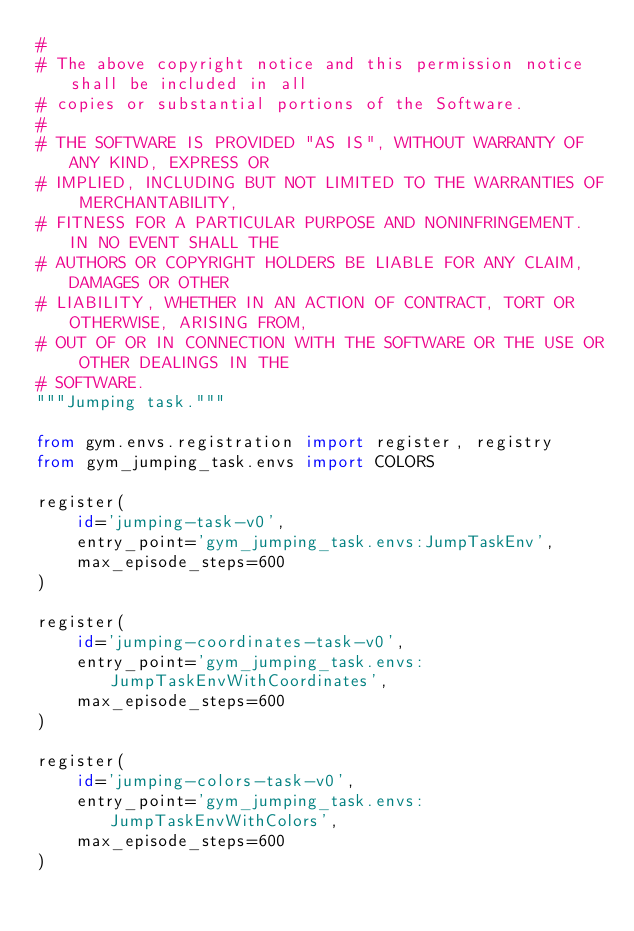<code> <loc_0><loc_0><loc_500><loc_500><_Python_>#
# The above copyright notice and this permission notice shall be included in all
# copies or substantial portions of the Software.
#
# THE SOFTWARE IS PROVIDED "AS IS", WITHOUT WARRANTY OF ANY KIND, EXPRESS OR
# IMPLIED, INCLUDING BUT NOT LIMITED TO THE WARRANTIES OF MERCHANTABILITY,
# FITNESS FOR A PARTICULAR PURPOSE AND NONINFRINGEMENT. IN NO EVENT SHALL THE
# AUTHORS OR COPYRIGHT HOLDERS BE LIABLE FOR ANY CLAIM, DAMAGES OR OTHER
# LIABILITY, WHETHER IN AN ACTION OF CONTRACT, TORT OR OTHERWISE, ARISING FROM,
# OUT OF OR IN CONNECTION WITH THE SOFTWARE OR THE USE OR OTHER DEALINGS IN THE
# SOFTWARE.
"""Jumping task."""

from gym.envs.registration import register, registry
from gym_jumping_task.envs import COLORS

register(
    id='jumping-task-v0',
    entry_point='gym_jumping_task.envs:JumpTaskEnv',
    max_episode_steps=600
)

register(
    id='jumping-coordinates-task-v0',
    entry_point='gym_jumping_task.envs:JumpTaskEnvWithCoordinates',
    max_episode_steps=600
)

register(
    id='jumping-colors-task-v0',
    entry_point='gym_jumping_task.envs:JumpTaskEnvWithColors',
    max_episode_steps=600
)
</code> 